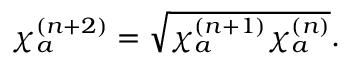Convert formula to latex. <formula><loc_0><loc_0><loc_500><loc_500>\begin{array} { r } { \chi _ { a } ^ { ( n + 2 ) } = \sqrt { \chi _ { a } ^ { ( n + 1 ) } \chi _ { a } ^ { ( n ) } } . } \end{array}</formula> 